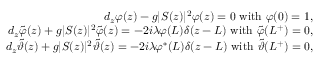Convert formula to latex. <formula><loc_0><loc_0><loc_500><loc_500>\begin{array} { r l r } & { d _ { z } \varphi ( z ) - g | S ( z ) | ^ { 2 } \varphi ( z ) = 0 \ w i t h \ \varphi ( 0 ) = 1 , } \\ & { d _ { z } \tilde { \varphi } ( z ) + g | S ( z ) | ^ { 2 } \tilde { \varphi } ( z ) = - 2 i \lambda \varphi ( L ) \delta ( z - L ) \ w i t h \ \tilde { \varphi } ( L ^ { + } ) = 0 , } \\ & { d _ { z } \tilde { \vartheta } ( z ) + g | S ( z ) | ^ { 2 } \tilde { \vartheta } ( z ) = - 2 i \lambda \varphi ^ { \ast } ( L ) \delta ( z - L ) \ w i t h \ \tilde { \vartheta } ( L ^ { + } ) = 0 , } \end{array}</formula> 